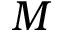Convert formula to latex. <formula><loc_0><loc_0><loc_500><loc_500>M</formula> 